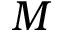Convert formula to latex. <formula><loc_0><loc_0><loc_500><loc_500>M</formula> 